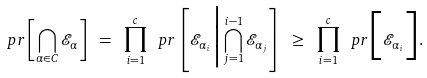<formula> <loc_0><loc_0><loc_500><loc_500>\ p r \left [ \bigcap _ { \alpha \in C } \mathcal { E } _ { \alpha } \right ] \ = \ \prod _ { i = 1 } ^ { c } \ p r \left [ \mathcal { E } _ { \alpha _ { i } } \Big | \bigcap _ { j = 1 } ^ { i - 1 } \mathcal { E } _ { \alpha _ { j } } \right ] \ \geq \ \prod _ { i = 1 } ^ { c } \ p r \Big [ \mathcal { E } _ { \alpha _ { i } } \Big ] .</formula> 